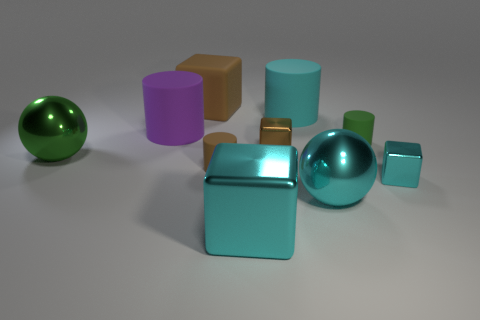There is a green thing that is on the right side of the brown matte cylinder; is it the same shape as the big brown matte object?
Your answer should be compact. No. Are there fewer large rubber objects in front of the big green metallic sphere than brown metal objects?
Offer a terse response. Yes. Are there any cyan balls that have the same material as the tiny brown block?
Keep it short and to the point. Yes. What material is the cyan cube that is the same size as the green cylinder?
Your answer should be very brief. Metal. Are there fewer green shiny balls that are to the right of the small brown metal block than small shiny blocks that are on the right side of the purple rubber thing?
Provide a succinct answer. Yes. What shape is the big metallic object that is left of the large cyan rubber object and in front of the small brown rubber cylinder?
Give a very brief answer. Cube. How many other green metal objects have the same shape as the large green shiny thing?
Offer a terse response. 0. What is the size of the brown thing that is made of the same material as the big green ball?
Make the answer very short. Small. Are there more purple matte things than things?
Give a very brief answer. No. The metallic ball right of the green shiny object is what color?
Your answer should be very brief. Cyan. 